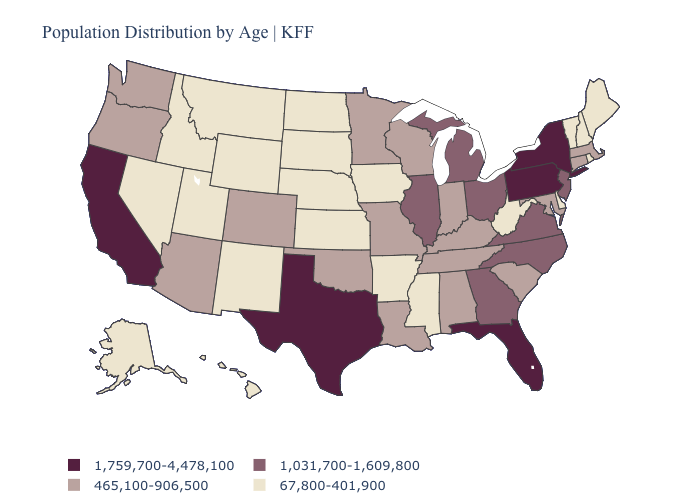Among the states that border Michigan , does Ohio have the lowest value?
Be succinct. No. Does the first symbol in the legend represent the smallest category?
Be succinct. No. Does the map have missing data?
Write a very short answer. No. What is the lowest value in the USA?
Give a very brief answer. 67,800-401,900. Does New Mexico have a higher value than Connecticut?
Write a very short answer. No. Does the first symbol in the legend represent the smallest category?
Give a very brief answer. No. Which states have the highest value in the USA?
Write a very short answer. California, Florida, New York, Pennsylvania, Texas. Does Kansas have the lowest value in the USA?
Concise answer only. Yes. How many symbols are there in the legend?
Write a very short answer. 4. What is the highest value in states that border Missouri?
Answer briefly. 1,031,700-1,609,800. What is the value of Alabama?
Keep it brief. 465,100-906,500. Name the states that have a value in the range 465,100-906,500?
Keep it brief. Alabama, Arizona, Colorado, Connecticut, Indiana, Kentucky, Louisiana, Maryland, Massachusetts, Minnesota, Missouri, Oklahoma, Oregon, South Carolina, Tennessee, Washington, Wisconsin. Among the states that border Illinois , does Kentucky have the highest value?
Concise answer only. Yes. What is the highest value in the USA?
Answer briefly. 1,759,700-4,478,100. What is the highest value in states that border Oklahoma?
Concise answer only. 1,759,700-4,478,100. 